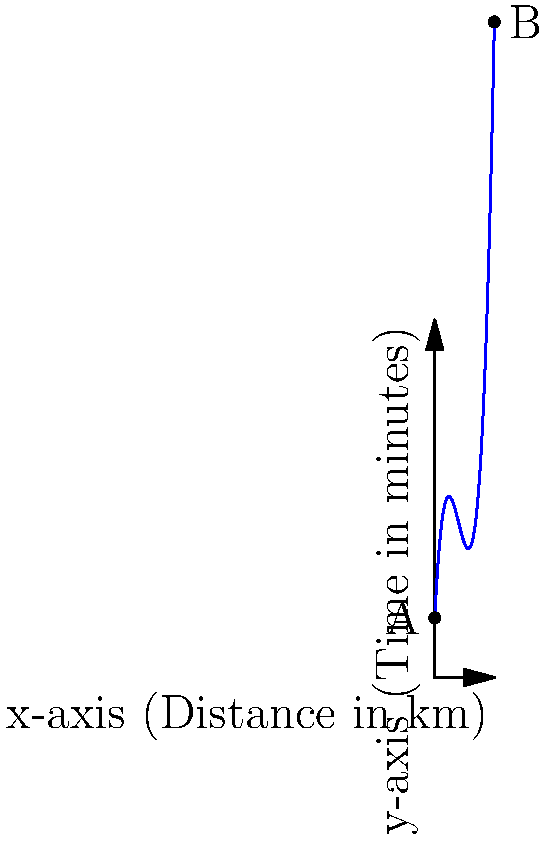A polynomial function models the time (in minutes) it takes for an emergency medical convoy to travel a certain distance (in km) through a war-torn region. The function is given by $T(x) = 0.5x^3 - 6x^2 + 20x + 10$, where $x$ is the distance traveled in kilometers. If the convoy needs to travel from point A (0 km) to point B (10 km), at what distance from the starting point should the convoy adjust its speed to minimize travel time? To find the optimal point to adjust speed, we need to find the minimum of the function $T(x)$ between 0 and 10 km.

1) First, we find the derivative of $T(x)$:
   $T'(x) = 1.5x^2 - 12x + 20$

2) To find the minimum, we set $T'(x) = 0$ and solve:
   $1.5x^2 - 12x + 20 = 0$

3) This is a quadratic equation. We can solve it using the quadratic formula:
   $x = \frac{-b \pm \sqrt{b^2 - 4ac}}{2a}$

   Where $a = 1.5$, $b = -12$, and $c = 20$

4) Plugging in these values:
   $x = \frac{12 \pm \sqrt{144 - 120}}{3} = \frac{12 \pm \sqrt{24}}{3} = \frac{12 \pm 2\sqrt{6}}{3}$

5) This gives us two solutions:
   $x_1 = \frac{12 + 2\sqrt{6}}{3} \approx 5.63$ km
   $x_2 = \frac{12 - 2\sqrt{6}}{3} \approx 2.37$ km

6) Since we're looking for a minimum between 0 and 10 km, and the function is a cubic (which has only one minimum), the solution we want is $x_2 \approx 2.37$ km.

Therefore, the convoy should adjust its speed approximately 2.37 km from the starting point to minimize travel time.
Answer: 2.37 km 